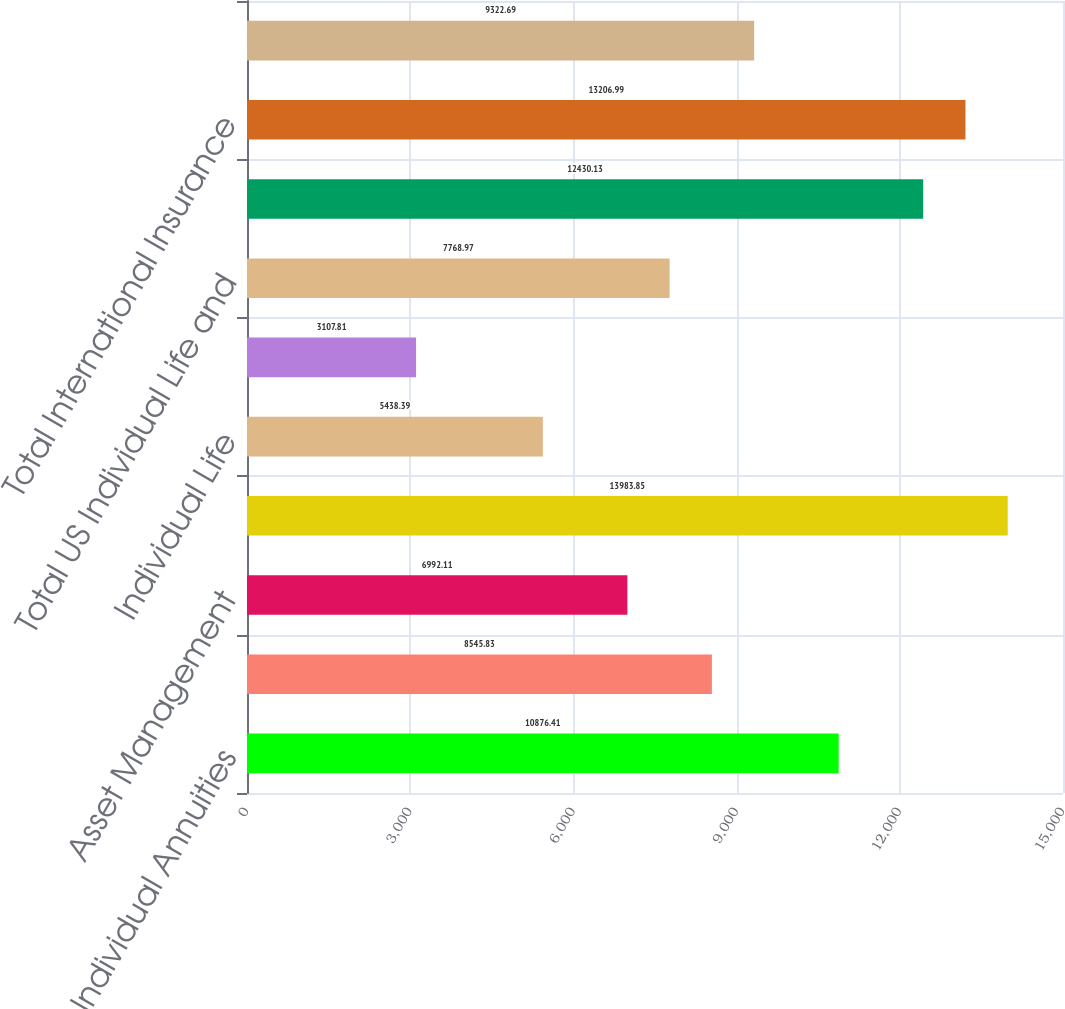Convert chart to OTSL. <chart><loc_0><loc_0><loc_500><loc_500><bar_chart><fcel>Individual Annuities<fcel>Retirement<fcel>Asset Management<fcel>Total US Retirement Solutions<fcel>Individual Life<fcel>Group Insurance<fcel>Total US Individual Life and<fcel>International Insurance<fcel>Total International Insurance<fcel>Corporate and Other operations<nl><fcel>10876.4<fcel>8545.83<fcel>6992.11<fcel>13983.9<fcel>5438.39<fcel>3107.81<fcel>7768.97<fcel>12430.1<fcel>13207<fcel>9322.69<nl></chart> 